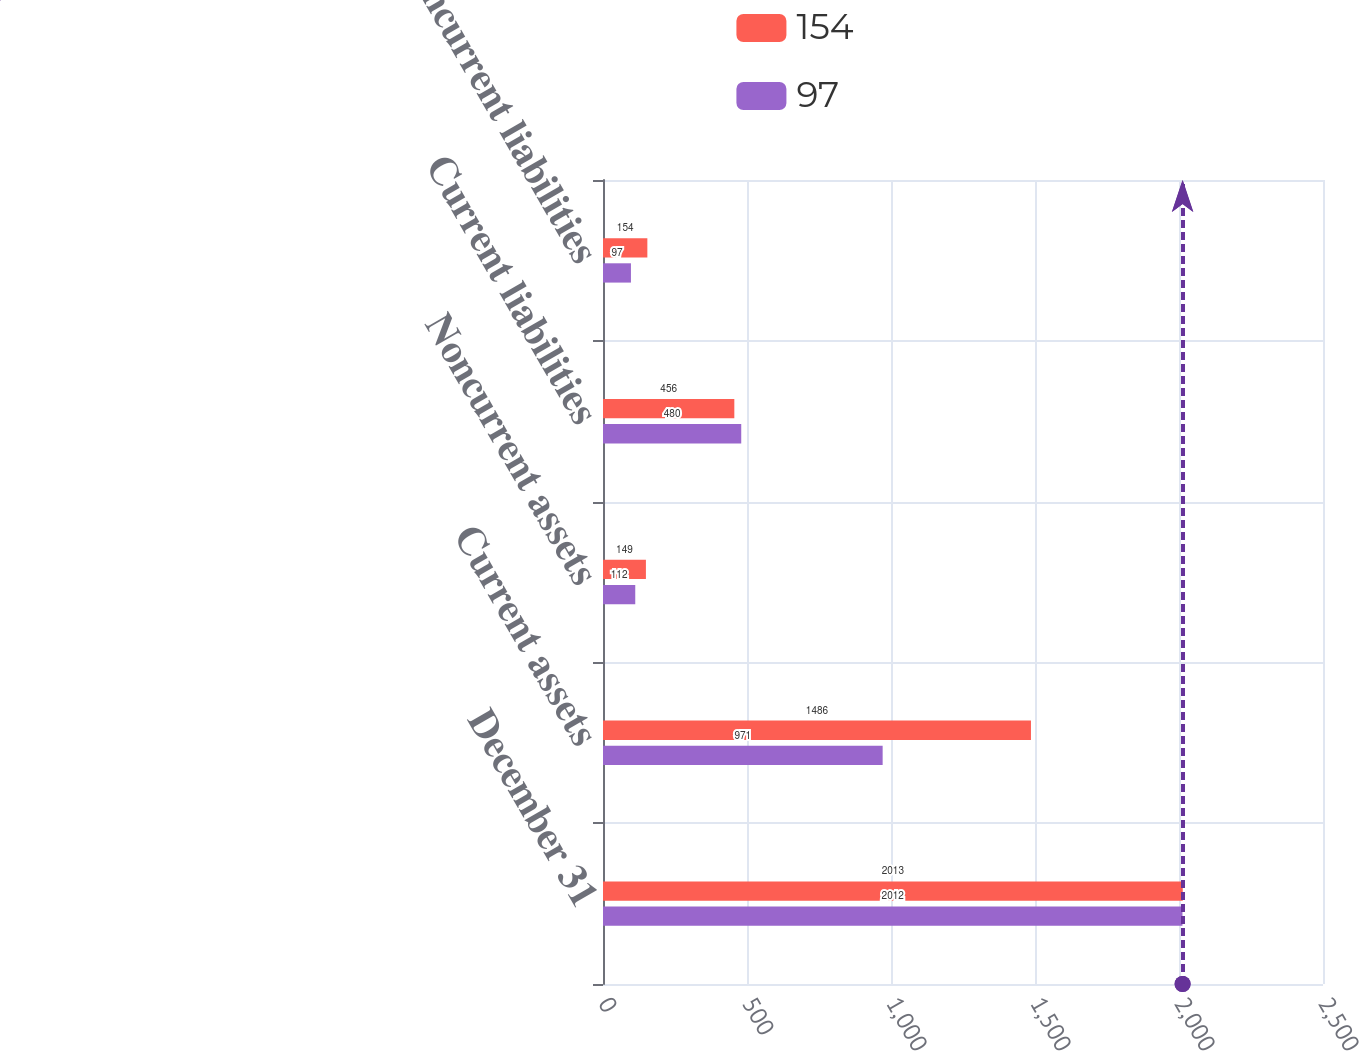Convert chart to OTSL. <chart><loc_0><loc_0><loc_500><loc_500><stacked_bar_chart><ecel><fcel>December 31<fcel>Current assets<fcel>Noncurrent assets<fcel>Current liabilities<fcel>Noncurrent liabilities<nl><fcel>154<fcel>2013<fcel>1486<fcel>149<fcel>456<fcel>154<nl><fcel>97<fcel>2012<fcel>971<fcel>112<fcel>480<fcel>97<nl></chart> 